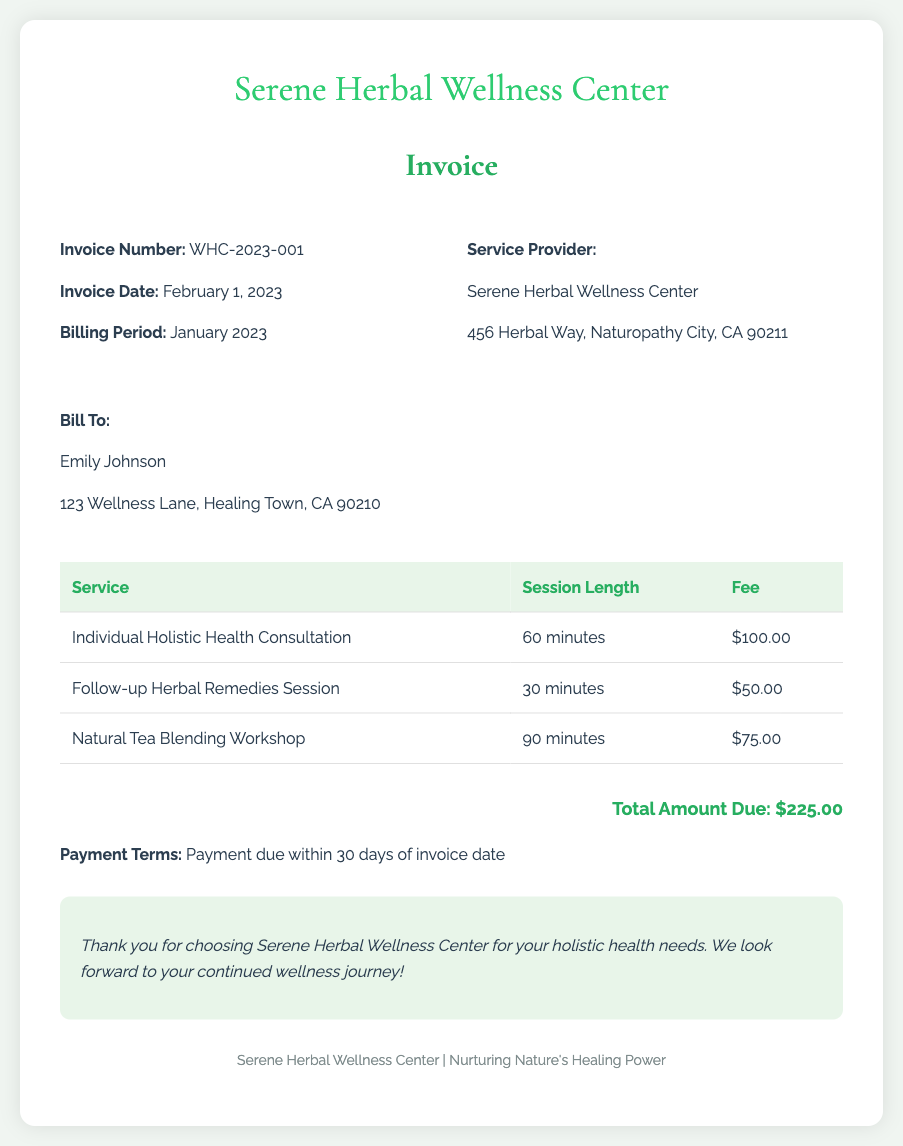What is the invoice number? The invoice number is listed at the top of the invoice, specifically labeled.
Answer: WHC-2023-001 What is the total amount due? The total amount due is found in the totals section of the invoice.
Answer: $225.00 Who is the service provider? The service provider's name is located in the invoice details section.
Answer: Serene Herbal Wellness Center What is the session length for the Individual Holistic Health Consultation? The session length is specified next to the corresponding service in the table.
Answer: 60 minutes What is the payment term stated in the document? The payment term is noted toward the end of the invoice, outlining the conditions for payment.
Answer: Payment due within 30 days of invoice date How many services are listed in the invoice? The number of services can be counted from the table provided in the document.
Answer: 3 What is the fee for the Follow-up Herbal Remedies Session? The fee is mentioned in the table next to the corresponding service.
Answer: $50.00 What is the billing period for this invoice? The billing period is stated under the invoice details section.
Answer: January 2023 What is the address of the service provider? The address is provided under the service provider's details in the document.
Answer: 456 Herbal Way, Naturopathy City, CA 90211 